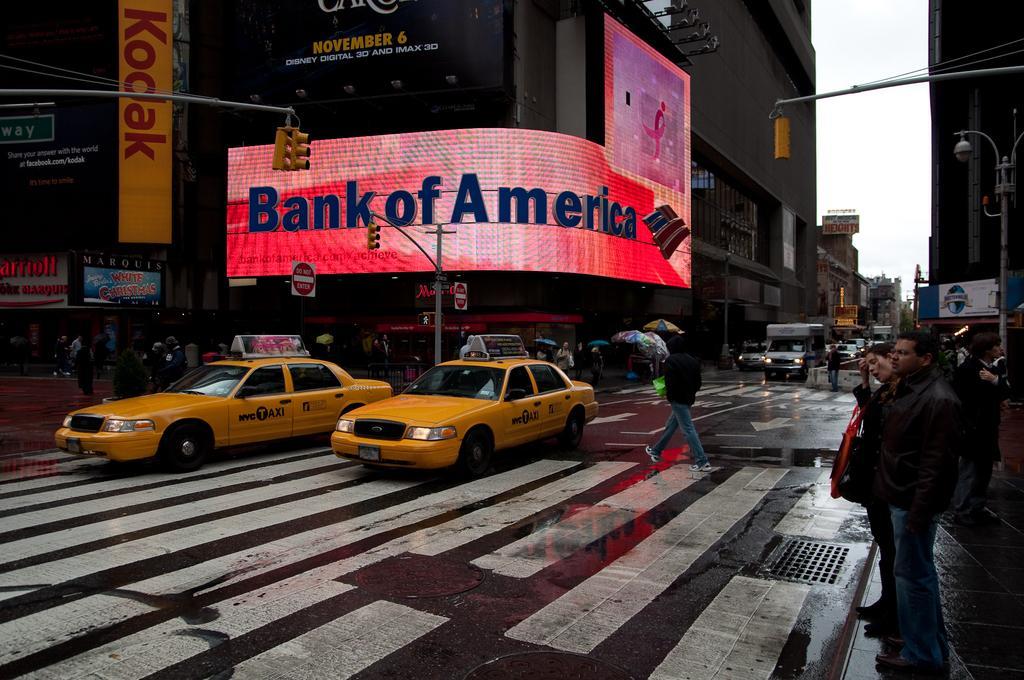Can you describe this image briefly? In this picture there are few vehicles on the road and there are few persons,buildings and traffic signals on either sides of it. 